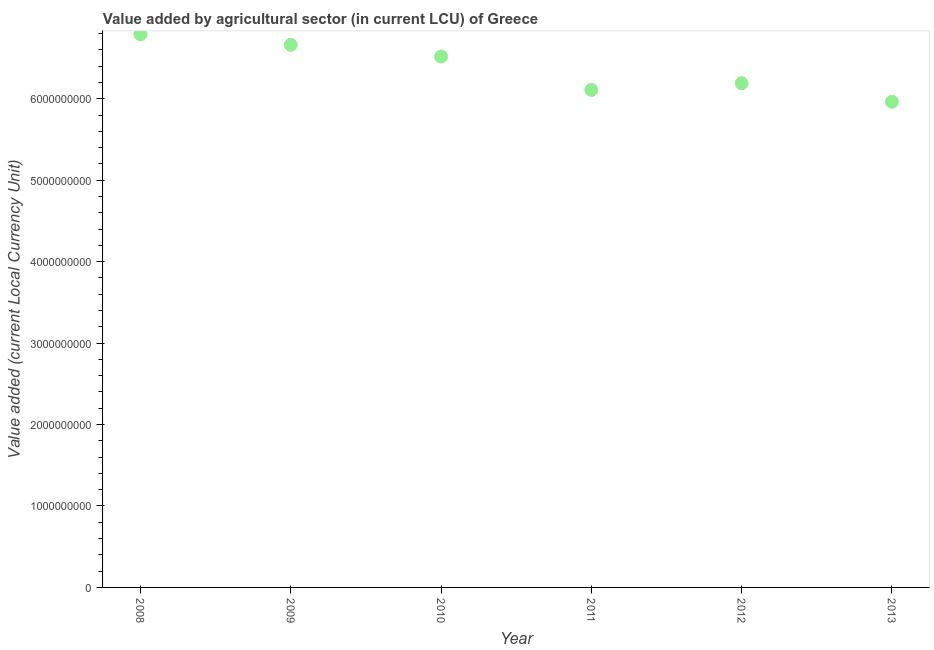What is the value added by agriculture sector in 2008?
Give a very brief answer. 6.79e+09. Across all years, what is the maximum value added by agriculture sector?
Make the answer very short. 6.79e+09. Across all years, what is the minimum value added by agriculture sector?
Your response must be concise. 5.96e+09. In which year was the value added by agriculture sector maximum?
Your answer should be very brief. 2008. What is the sum of the value added by agriculture sector?
Offer a very short reply. 3.82e+1. What is the difference between the value added by agriculture sector in 2008 and 2011?
Offer a terse response. 6.84e+08. What is the average value added by agriculture sector per year?
Your response must be concise. 6.37e+09. What is the median value added by agriculture sector?
Your answer should be very brief. 6.35e+09. In how many years, is the value added by agriculture sector greater than 800000000 LCU?
Your answer should be very brief. 6. What is the ratio of the value added by agriculture sector in 2010 to that in 2011?
Ensure brevity in your answer.  1.07. What is the difference between the highest and the second highest value added by agriculture sector?
Provide a succinct answer. 1.31e+08. Is the sum of the value added by agriculture sector in 2008 and 2009 greater than the maximum value added by agriculture sector across all years?
Your answer should be very brief. Yes. What is the difference between the highest and the lowest value added by agriculture sector?
Your answer should be very brief. 8.29e+08. How many dotlines are there?
Your answer should be compact. 1. What is the difference between two consecutive major ticks on the Y-axis?
Ensure brevity in your answer.  1.00e+09. Does the graph contain grids?
Keep it short and to the point. No. What is the title of the graph?
Ensure brevity in your answer.  Value added by agricultural sector (in current LCU) of Greece. What is the label or title of the X-axis?
Your answer should be compact. Year. What is the label or title of the Y-axis?
Offer a terse response. Value added (current Local Currency Unit). What is the Value added (current Local Currency Unit) in 2008?
Your answer should be compact. 6.79e+09. What is the Value added (current Local Currency Unit) in 2009?
Your answer should be very brief. 6.66e+09. What is the Value added (current Local Currency Unit) in 2010?
Ensure brevity in your answer.  6.52e+09. What is the Value added (current Local Currency Unit) in 2011?
Provide a short and direct response. 6.11e+09. What is the Value added (current Local Currency Unit) in 2012?
Make the answer very short. 6.19e+09. What is the Value added (current Local Currency Unit) in 2013?
Keep it short and to the point. 5.96e+09. What is the difference between the Value added (current Local Currency Unit) in 2008 and 2009?
Offer a terse response. 1.31e+08. What is the difference between the Value added (current Local Currency Unit) in 2008 and 2010?
Your response must be concise. 2.74e+08. What is the difference between the Value added (current Local Currency Unit) in 2008 and 2011?
Your answer should be compact. 6.84e+08. What is the difference between the Value added (current Local Currency Unit) in 2008 and 2012?
Provide a short and direct response. 6.03e+08. What is the difference between the Value added (current Local Currency Unit) in 2008 and 2013?
Your response must be concise. 8.29e+08. What is the difference between the Value added (current Local Currency Unit) in 2009 and 2010?
Make the answer very short. 1.44e+08. What is the difference between the Value added (current Local Currency Unit) in 2009 and 2011?
Keep it short and to the point. 5.54e+08. What is the difference between the Value added (current Local Currency Unit) in 2009 and 2012?
Provide a short and direct response. 4.72e+08. What is the difference between the Value added (current Local Currency Unit) in 2009 and 2013?
Make the answer very short. 6.99e+08. What is the difference between the Value added (current Local Currency Unit) in 2010 and 2011?
Provide a succinct answer. 4.10e+08. What is the difference between the Value added (current Local Currency Unit) in 2010 and 2012?
Your response must be concise. 3.28e+08. What is the difference between the Value added (current Local Currency Unit) in 2010 and 2013?
Make the answer very short. 5.55e+08. What is the difference between the Value added (current Local Currency Unit) in 2011 and 2012?
Keep it short and to the point. -8.18e+07. What is the difference between the Value added (current Local Currency Unit) in 2011 and 2013?
Your answer should be compact. 1.45e+08. What is the difference between the Value added (current Local Currency Unit) in 2012 and 2013?
Keep it short and to the point. 2.27e+08. What is the ratio of the Value added (current Local Currency Unit) in 2008 to that in 2010?
Provide a short and direct response. 1.04. What is the ratio of the Value added (current Local Currency Unit) in 2008 to that in 2011?
Give a very brief answer. 1.11. What is the ratio of the Value added (current Local Currency Unit) in 2008 to that in 2012?
Your answer should be compact. 1.1. What is the ratio of the Value added (current Local Currency Unit) in 2008 to that in 2013?
Your answer should be very brief. 1.14. What is the ratio of the Value added (current Local Currency Unit) in 2009 to that in 2010?
Keep it short and to the point. 1.02. What is the ratio of the Value added (current Local Currency Unit) in 2009 to that in 2011?
Your answer should be compact. 1.09. What is the ratio of the Value added (current Local Currency Unit) in 2009 to that in 2012?
Make the answer very short. 1.08. What is the ratio of the Value added (current Local Currency Unit) in 2009 to that in 2013?
Your answer should be very brief. 1.12. What is the ratio of the Value added (current Local Currency Unit) in 2010 to that in 2011?
Ensure brevity in your answer.  1.07. What is the ratio of the Value added (current Local Currency Unit) in 2010 to that in 2012?
Keep it short and to the point. 1.05. What is the ratio of the Value added (current Local Currency Unit) in 2010 to that in 2013?
Your response must be concise. 1.09. What is the ratio of the Value added (current Local Currency Unit) in 2011 to that in 2012?
Keep it short and to the point. 0.99. What is the ratio of the Value added (current Local Currency Unit) in 2012 to that in 2013?
Give a very brief answer. 1.04. 